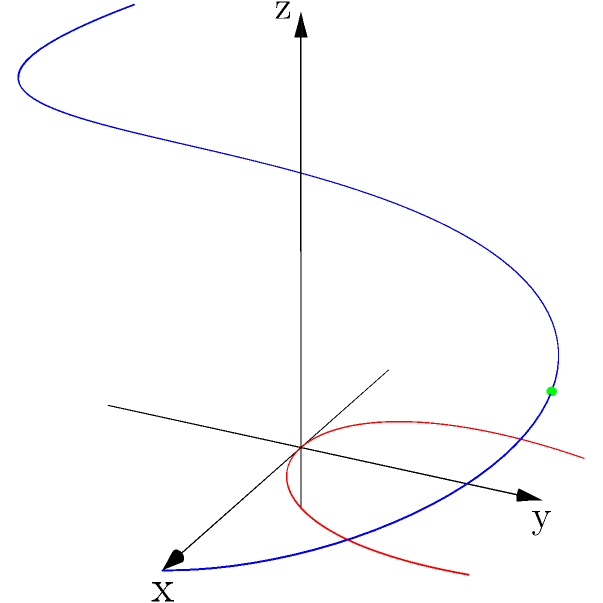In the 3D space shown above, we have two parametric curves: a blue helix defined by $r_1(t) = (\cos t, \sin t, t)$ and a red curve defined by $r_2(t) = (t, t^2, t^3)$. At which point do these curves intersect, and what is the corresponding parameter value $t$ for each curve at this intersection point? To find the intersection point, we need to equate the components of both parametric equations:

1) First, let's equate the components:
   $\cos t_1 = t_2$
   $\sin t_1 = t_2^2$
   $t_1 = t_2^3$

2) From the third equation, we can substitute $t_1 = t_2^3$ into the first two equations:
   $\cos(t_2^3) = t_2$
   $\sin(t_2^3) = t_2^2$

3) We can see that when $t_2 = \frac{\pi}{2}$, the equations are satisfied:
   $\cos((\frac{\pi}{2})^3) = \cos(\frac{\pi}{2}) = 0 = \frac{\pi}{2}$
   $\sin((\frac{\pi}{2})^3) = \sin(\frac{\pi}{2}) = 1 = (\frac{\pi}{2})^2$

4) Therefore, for the second curve, $t_2 = \frac{\pi}{2}$.

5) For the first curve, $t_1 = t_2^3 = (\frac{\pi}{2})^3 = \frac{\pi^3}{8}$.

6) We can verify the intersection point by plugging these t values into their respective equations:
   $r_1(\frac{\pi^3}{8}) = (\cos(\frac{\pi^3}{8}), \sin(\frac{\pi^3}{8}), \frac{\pi^3}{8}) \approx (0, 1, 3.08)$
   $r_2(\frac{\pi}{2}) = (\frac{\pi}{2}, (\frac{\pi}{2})^2, (\frac{\pi}{2})^3) = (\frac{\pi}{2}, \frac{\pi^2}{4}, \frac{\pi^3}{8}) \approx (1.57, 2.47, 3.08)$

The intersection point is approximately $(0, 1, 3.08)$, which is represented by the green dot in the diagram.
Answer: Intersection at $(0, 1, \frac{\pi^3}{8})$; $t_1 = \frac{\pi^3}{8}$ for $r_1$, $t_2 = \frac{\pi}{2}$ for $r_2$ 